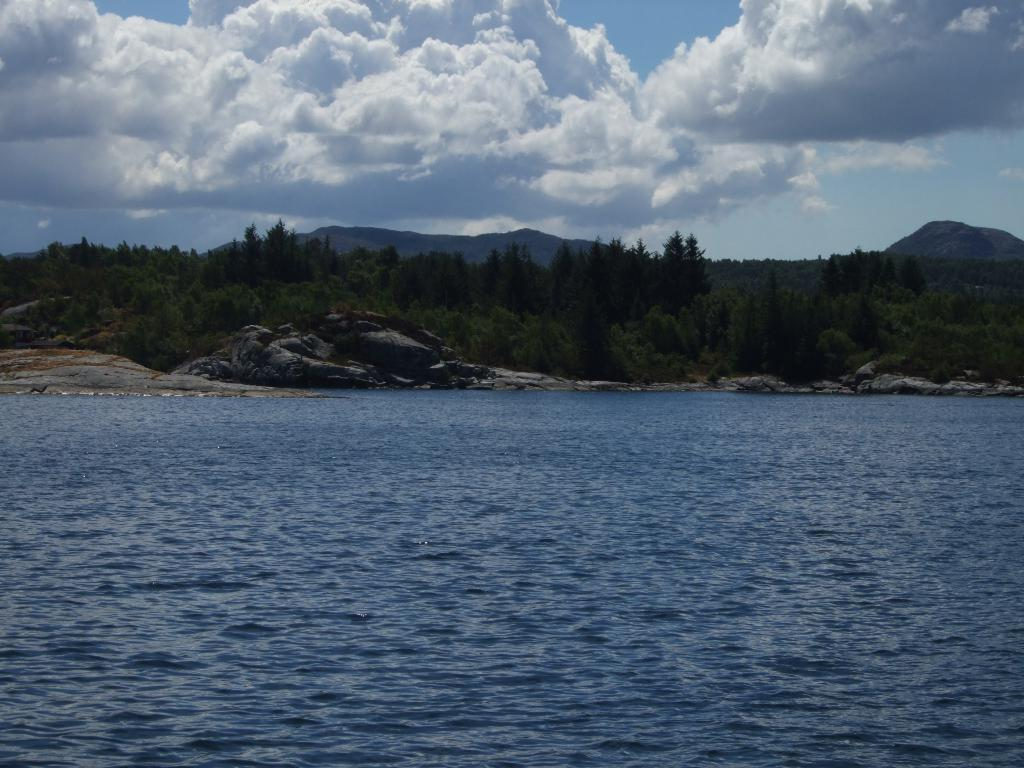What color is the water in the image? The water in the image is blue. What can be seen in the background of the image? There are many trees, mountains, clouds, and the sky visible in the background of the image. What type of thread is being used to sew the clouds together in the image? There is no thread or sewing activity present in the image; the clouds are naturally occurring in the sky. 